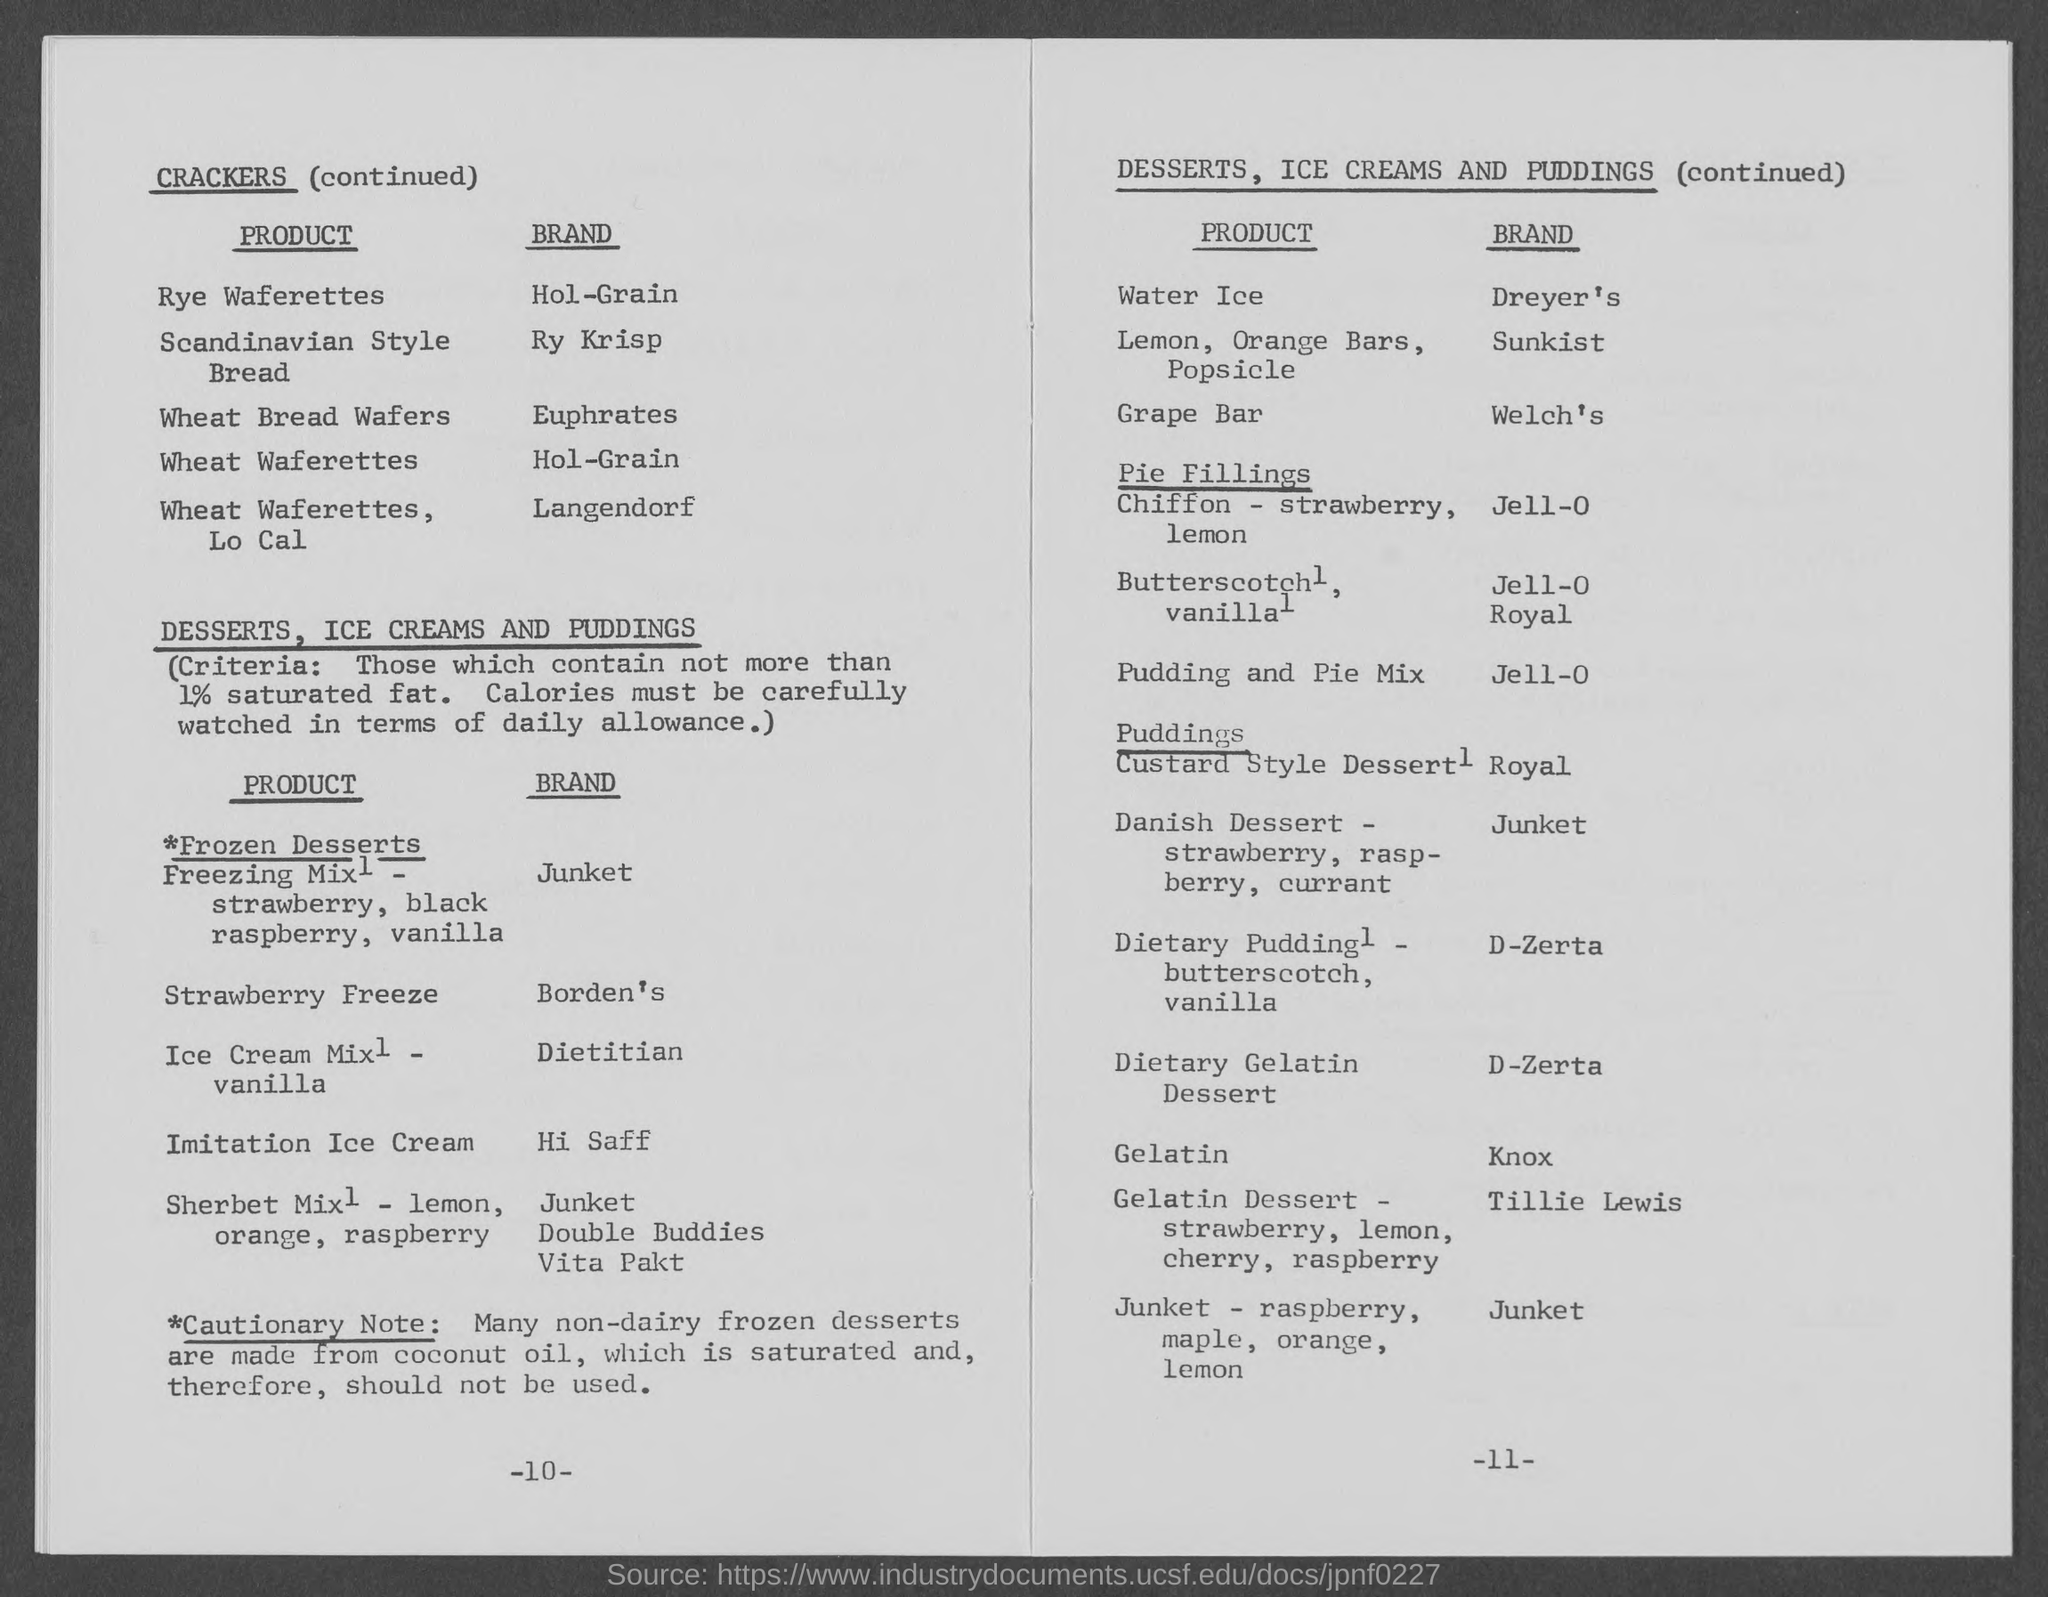Identify some key points in this picture. Gelatin is the type of pudding that is related to the brand "Knox. Dreyer's is the brand given against Water Ice. The first column under the heading "crackers" in the two-column table is titled "Product". Under the heading "crackers," Scandinavian Style Bread is listed with the brand "ry krisp. The second column under the heading "crackers" in the given table is titled "brand. 